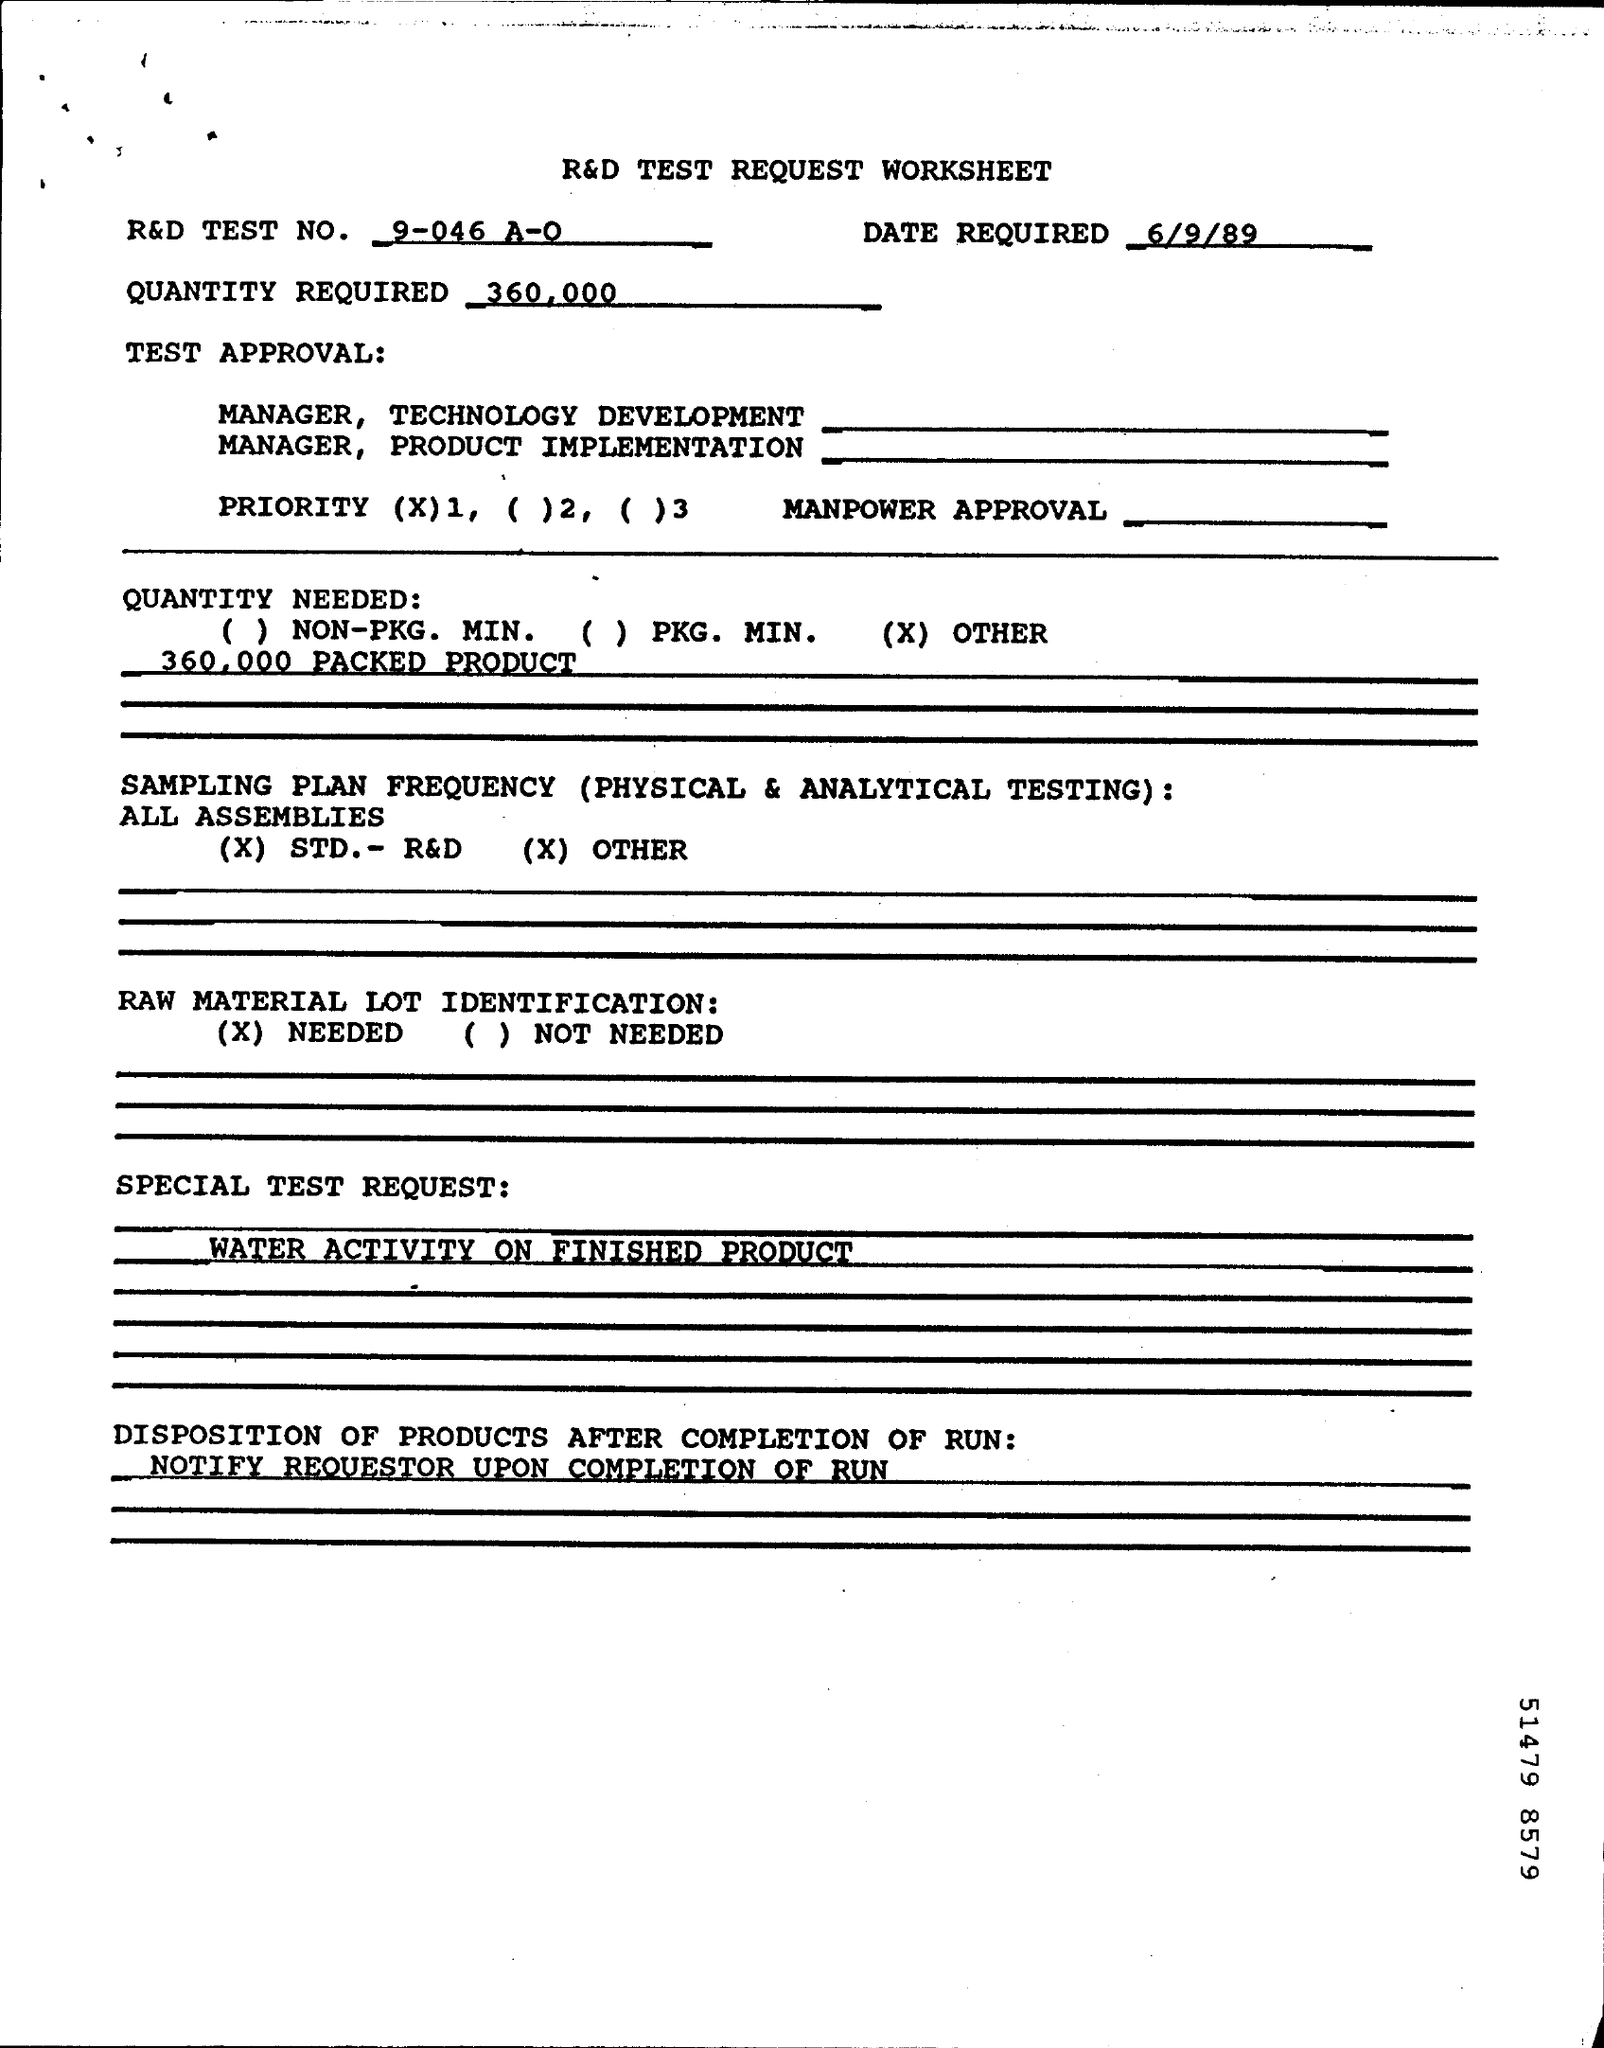Mention a couple of crucial points in this snapshot. The R&D Test Number is 9-046 A-O. The memorandum was dated on June 9, 1989. We will require 360,000 units for this project. 